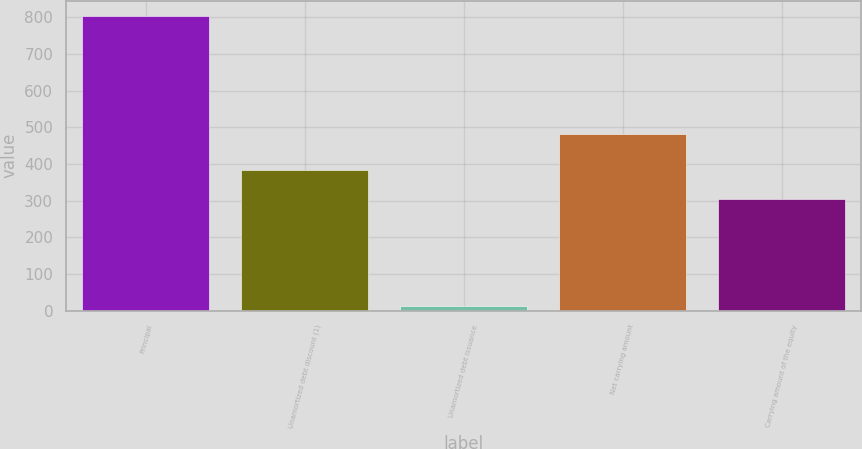Convert chart. <chart><loc_0><loc_0><loc_500><loc_500><bar_chart><fcel>Principal<fcel>Unamortized debt discount (1)<fcel>Unamortized debt issuance<fcel>Net carrying amount<fcel>Carrying amount of the equity<nl><fcel>805<fcel>384.1<fcel>14<fcel>483<fcel>305<nl></chart> 